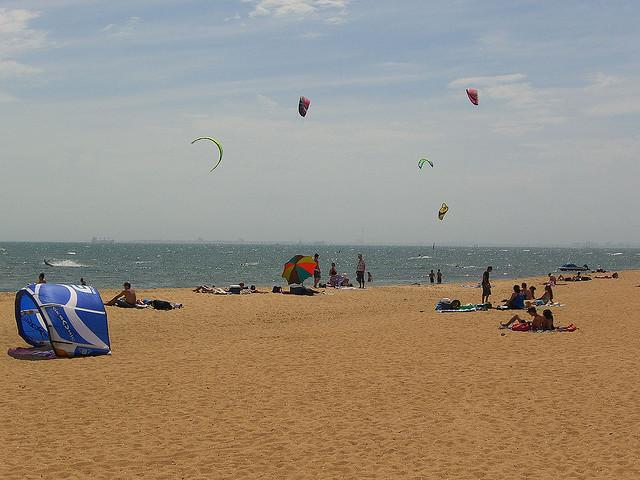What caused all the indents in the sand? Please explain your reasoning. foot traffic. Many people have walked on it 